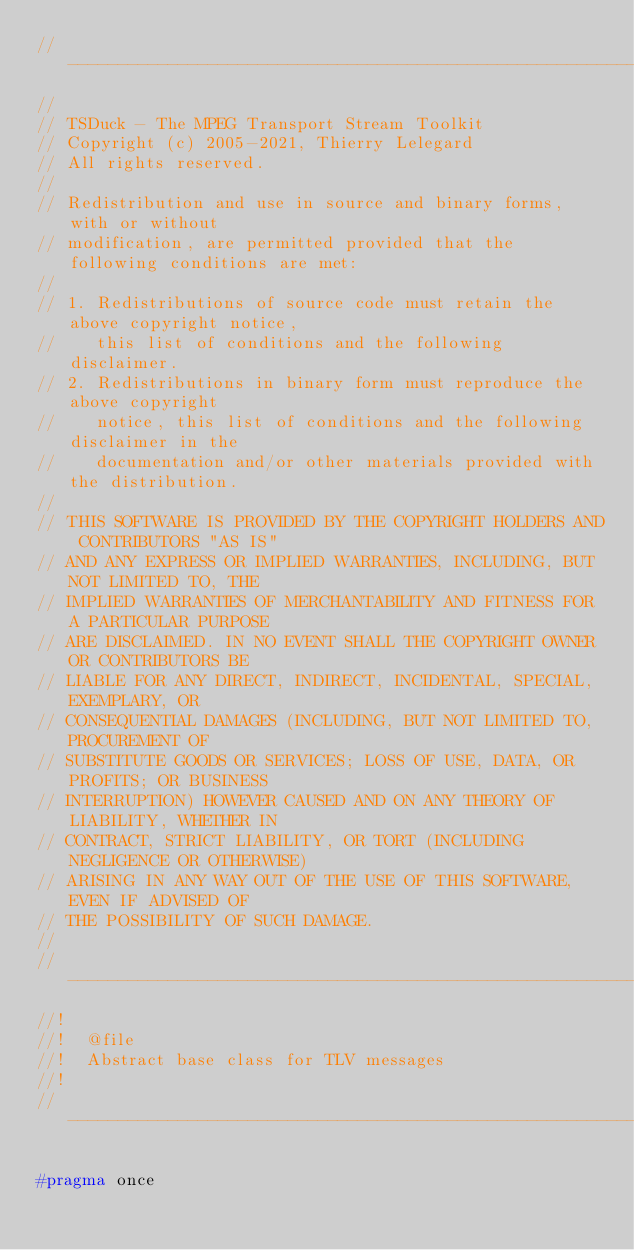<code> <loc_0><loc_0><loc_500><loc_500><_C_>//----------------------------------------------------------------------------
//
// TSDuck - The MPEG Transport Stream Toolkit
// Copyright (c) 2005-2021, Thierry Lelegard
// All rights reserved.
//
// Redistribution and use in source and binary forms, with or without
// modification, are permitted provided that the following conditions are met:
//
// 1. Redistributions of source code must retain the above copyright notice,
//    this list of conditions and the following disclaimer.
// 2. Redistributions in binary form must reproduce the above copyright
//    notice, this list of conditions and the following disclaimer in the
//    documentation and/or other materials provided with the distribution.
//
// THIS SOFTWARE IS PROVIDED BY THE COPYRIGHT HOLDERS AND CONTRIBUTORS "AS IS"
// AND ANY EXPRESS OR IMPLIED WARRANTIES, INCLUDING, BUT NOT LIMITED TO, THE
// IMPLIED WARRANTIES OF MERCHANTABILITY AND FITNESS FOR A PARTICULAR PURPOSE
// ARE DISCLAIMED. IN NO EVENT SHALL THE COPYRIGHT OWNER OR CONTRIBUTORS BE
// LIABLE FOR ANY DIRECT, INDIRECT, INCIDENTAL, SPECIAL, EXEMPLARY, OR
// CONSEQUENTIAL DAMAGES (INCLUDING, BUT NOT LIMITED TO, PROCUREMENT OF
// SUBSTITUTE GOODS OR SERVICES; LOSS OF USE, DATA, OR PROFITS; OR BUSINESS
// INTERRUPTION) HOWEVER CAUSED AND ON ANY THEORY OF LIABILITY, WHETHER IN
// CONTRACT, STRICT LIABILITY, OR TORT (INCLUDING NEGLIGENCE OR OTHERWISE)
// ARISING IN ANY WAY OUT OF THE USE OF THIS SOFTWARE, EVEN IF ADVISED OF
// THE POSSIBILITY OF SUCH DAMAGE.
//
//----------------------------------------------------------------------------
//!
//!  @file
//!  Abstract base class for TLV messages
//!
//----------------------------------------------------------------------------

#pragma once</code> 